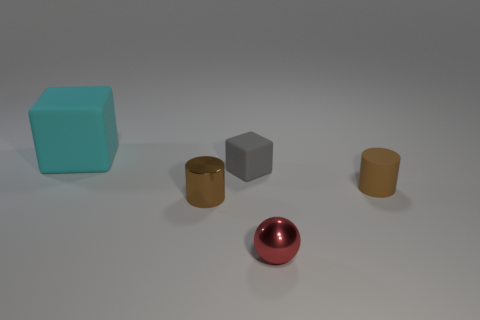There is a gray matte block; are there any big cyan cubes behind it?
Provide a short and direct response. Yes. How many small rubber things have the same shape as the brown shiny thing?
Keep it short and to the point. 1. Is the material of the large cyan cube the same as the small brown thing behind the small shiny cylinder?
Provide a short and direct response. Yes. What number of tiny blue balls are there?
Your answer should be very brief. 0. What size is the cylinder that is behind the tiny brown shiny thing?
Your response must be concise. Small. How many rubber cylinders have the same size as the metal cylinder?
Provide a succinct answer. 1. There is a object that is both behind the small brown shiny thing and to the left of the small gray block; what is its material?
Ensure brevity in your answer.  Rubber. What material is the gray cube that is the same size as the brown matte cylinder?
Give a very brief answer. Rubber. What is the size of the metallic object that is on the right side of the brown cylinder in front of the tiny rubber object that is right of the tiny gray matte block?
Ensure brevity in your answer.  Small. The brown cylinder that is the same material as the gray thing is what size?
Offer a very short reply. Small. 